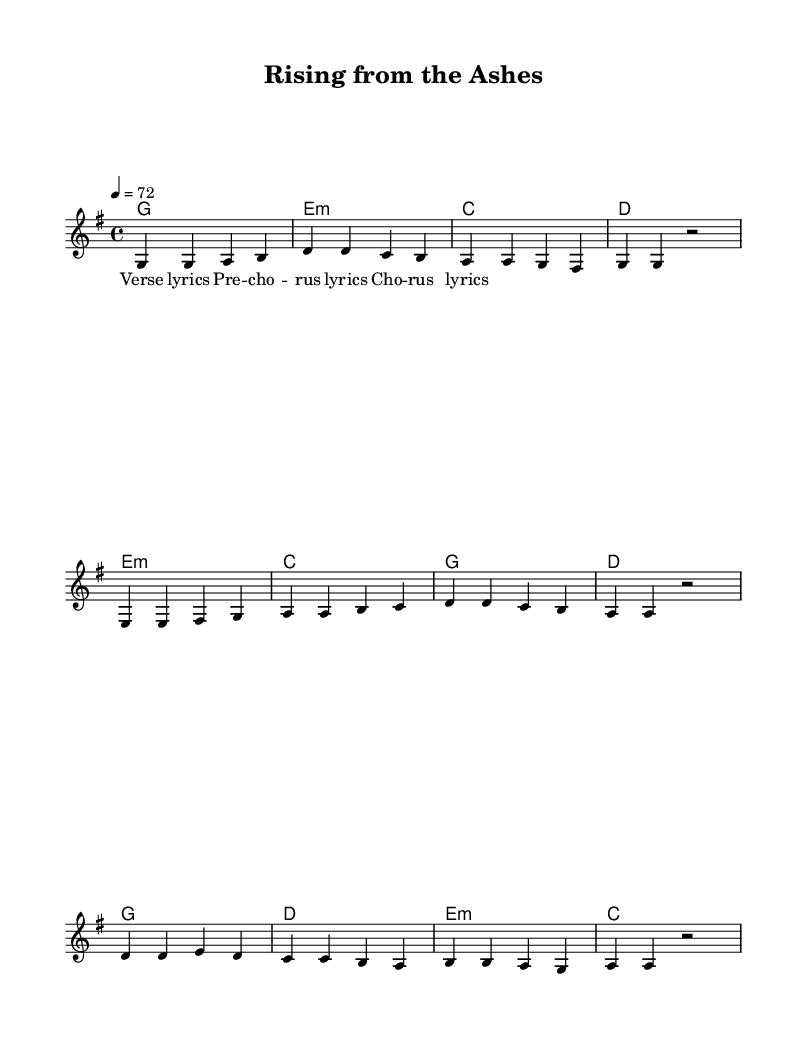What is the key signature of this music? The key signature shows one sharp, indicating it is in the key of G major.
Answer: G major What is the time signature of this piece? The time signature displayed is 4/4, which means there are four beats per measure and the quarter note gets one beat.
Answer: 4/4 What is the tempo marking of the piece? The tempo marking indicates a speed of 72 beats per minute, meaning the quarter note is played at this rate.
Answer: 72 What is the first chord in the verse? The first chord of the melody is indicated in the chord section, which shows G major as the first chord in the verse.
Answer: G How many measures are in the chorus? The chorus section contains four measures with specific rhythms and chords that culminate together.
Answer: 4 Which part of the song follows the pre-chorus? The part that immediately follows the pre-chorus is the chorus, which is evident from the structure laid out in the score.
Answer: Chorus How many times is the letter "a" found in the chorus lyrics? By counting the occurrences of the letter "a" in the chorus lyrics section, we find it appears four times in the respective words.
Answer: 4 